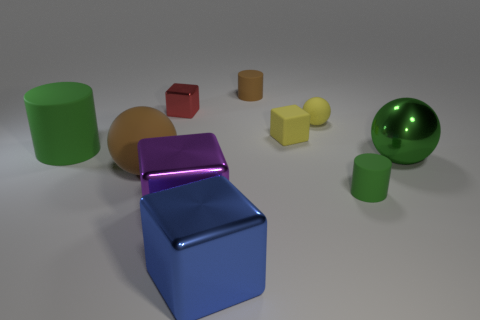What number of small matte cubes are to the right of the big ball left of the yellow ball?
Give a very brief answer. 1. What number of shiny things are either tiny cylinders or small brown objects?
Your answer should be very brief. 0. Are there any purple things that have the same material as the tiny green thing?
Your answer should be compact. No. How many objects are either cylinders behind the small green matte cylinder or large spheres to the left of the small red metal block?
Provide a succinct answer. 3. Do the big sphere right of the tiny red shiny object and the tiny metal cube have the same color?
Provide a short and direct response. No. What number of other objects are there of the same color as the small ball?
Offer a terse response. 1. What material is the purple object?
Your answer should be compact. Metal. Do the brown matte object to the right of the blue shiny cube and the large rubber sphere have the same size?
Make the answer very short. No. Is there anything else that has the same size as the blue metallic thing?
Provide a short and direct response. Yes. There is another yellow object that is the same shape as the tiny metal object; what is its size?
Your answer should be compact. Small. 